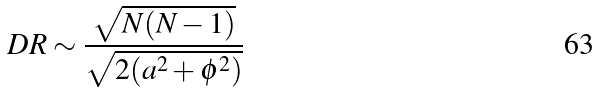<formula> <loc_0><loc_0><loc_500><loc_500>D R \sim \frac { \sqrt { N ( N - 1 ) } } { \sqrt { 2 ( a ^ { 2 } + \phi ^ { 2 } ) } }</formula> 